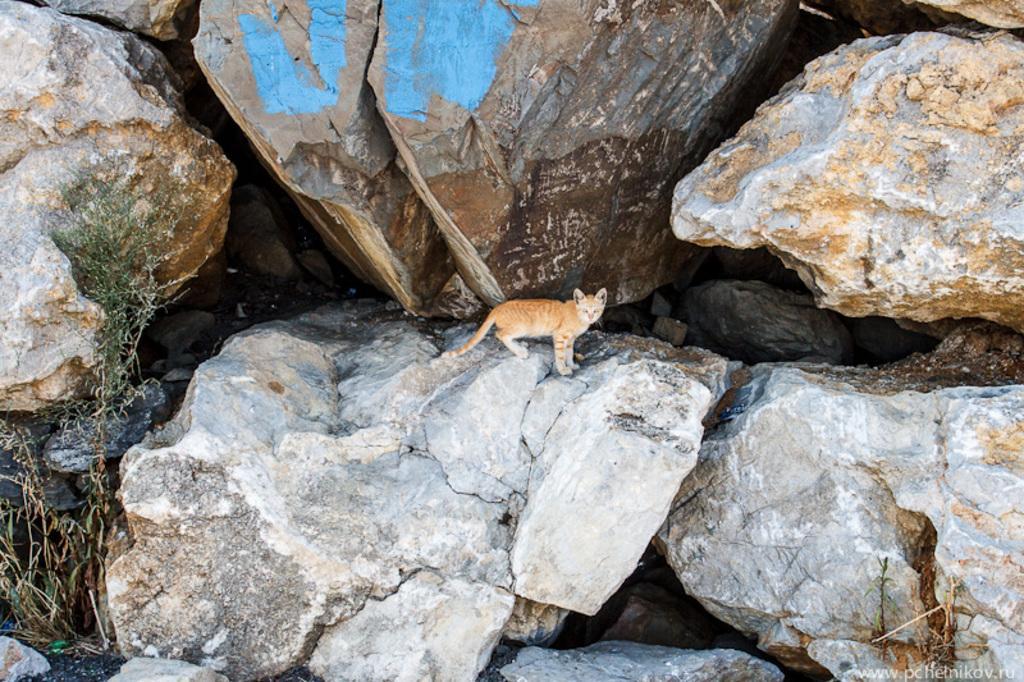How would you summarize this image in a sentence or two? On this rock there is a cat. Left side we can see plant. Right side bottom of the image there is a watermark. 